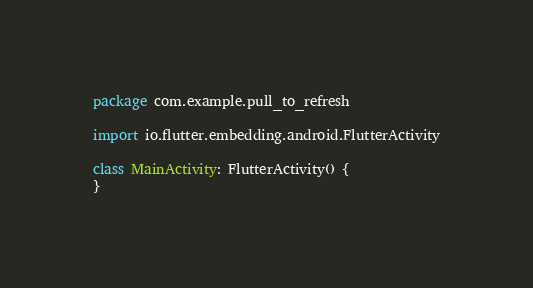Convert code to text. <code><loc_0><loc_0><loc_500><loc_500><_Kotlin_>package com.example.pull_to_refresh

import io.flutter.embedding.android.FlutterActivity

class MainActivity: FlutterActivity() {
}
</code> 